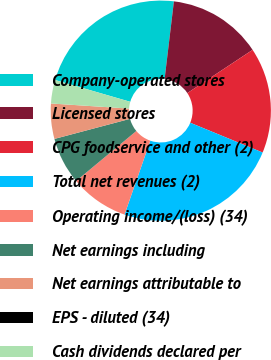Convert chart. <chart><loc_0><loc_0><loc_500><loc_500><pie_chart><fcel>Company-operated stores<fcel>Licensed stores<fcel>CPG foodservice and other (2)<fcel>Total net revenues (2)<fcel>Operating income/(loss) (34)<fcel>Net earnings including<fcel>Net earnings attributable to<fcel>EPS - diluted (34)<fcel>Cash dividends declared per<nl><fcel>22.41%<fcel>13.79%<fcel>15.52%<fcel>24.14%<fcel>8.62%<fcel>6.9%<fcel>5.17%<fcel>0.0%<fcel>3.45%<nl></chart> 